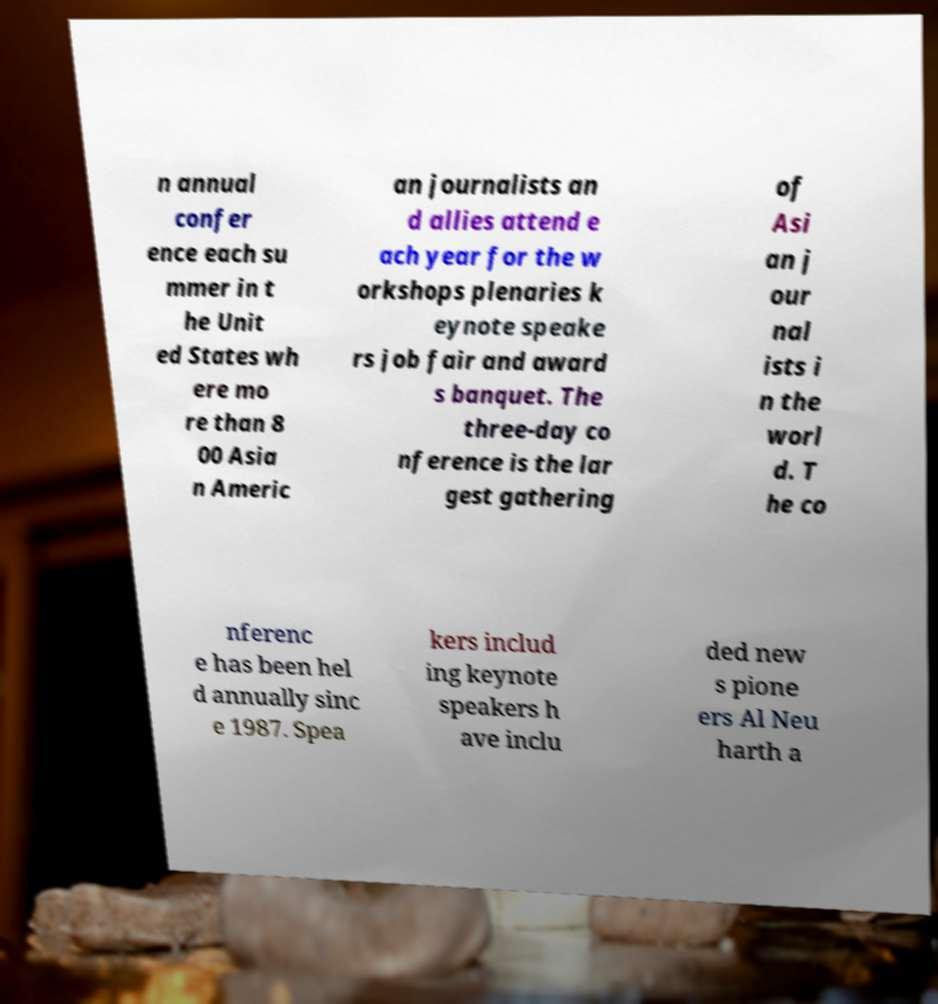For documentation purposes, I need the text within this image transcribed. Could you provide that? n annual confer ence each su mmer in t he Unit ed States wh ere mo re than 8 00 Asia n Americ an journalists an d allies attend e ach year for the w orkshops plenaries k eynote speake rs job fair and award s banquet. The three-day co nference is the lar gest gathering of Asi an j our nal ists i n the worl d. T he co nferenc e has been hel d annually sinc e 1987. Spea kers includ ing keynote speakers h ave inclu ded new s pione ers Al Neu harth a 